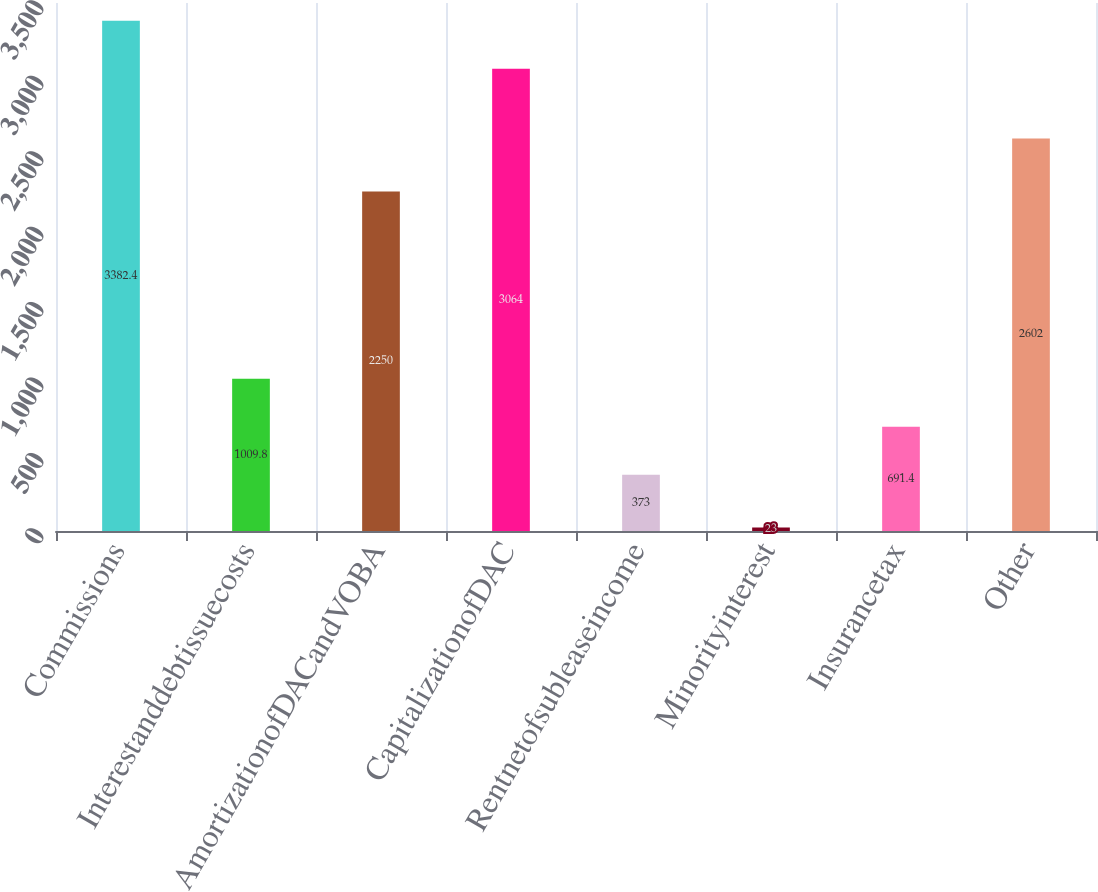Convert chart. <chart><loc_0><loc_0><loc_500><loc_500><bar_chart><fcel>Commissions<fcel>Interestanddebtissuecosts<fcel>AmortizationofDACandVOBA<fcel>CapitalizationofDAC<fcel>Rentnetofsubleaseincome<fcel>Minorityinterest<fcel>Insurancetax<fcel>Other<nl><fcel>3382.4<fcel>1009.8<fcel>2250<fcel>3064<fcel>373<fcel>23<fcel>691.4<fcel>2602<nl></chart> 